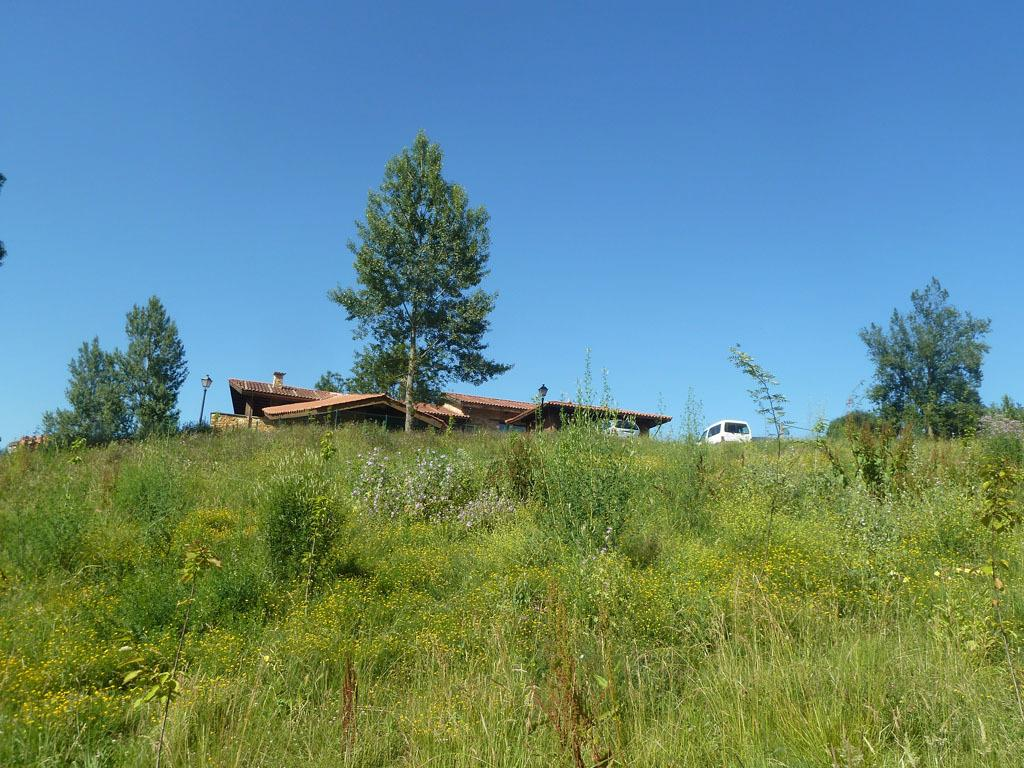What type of vegetation can be seen in the image? There are trees on the grassland in the image. What structure is located behind the trees? There is a building behind the trees. What is visible behind the building in the image? There is a vehicle behind the building. What part of the natural environment is visible in the image? The sky is visible above the scene. What type of pancake is being served in the afternoon in the image? There is no pancake or reference to a specific time of day in the image. 